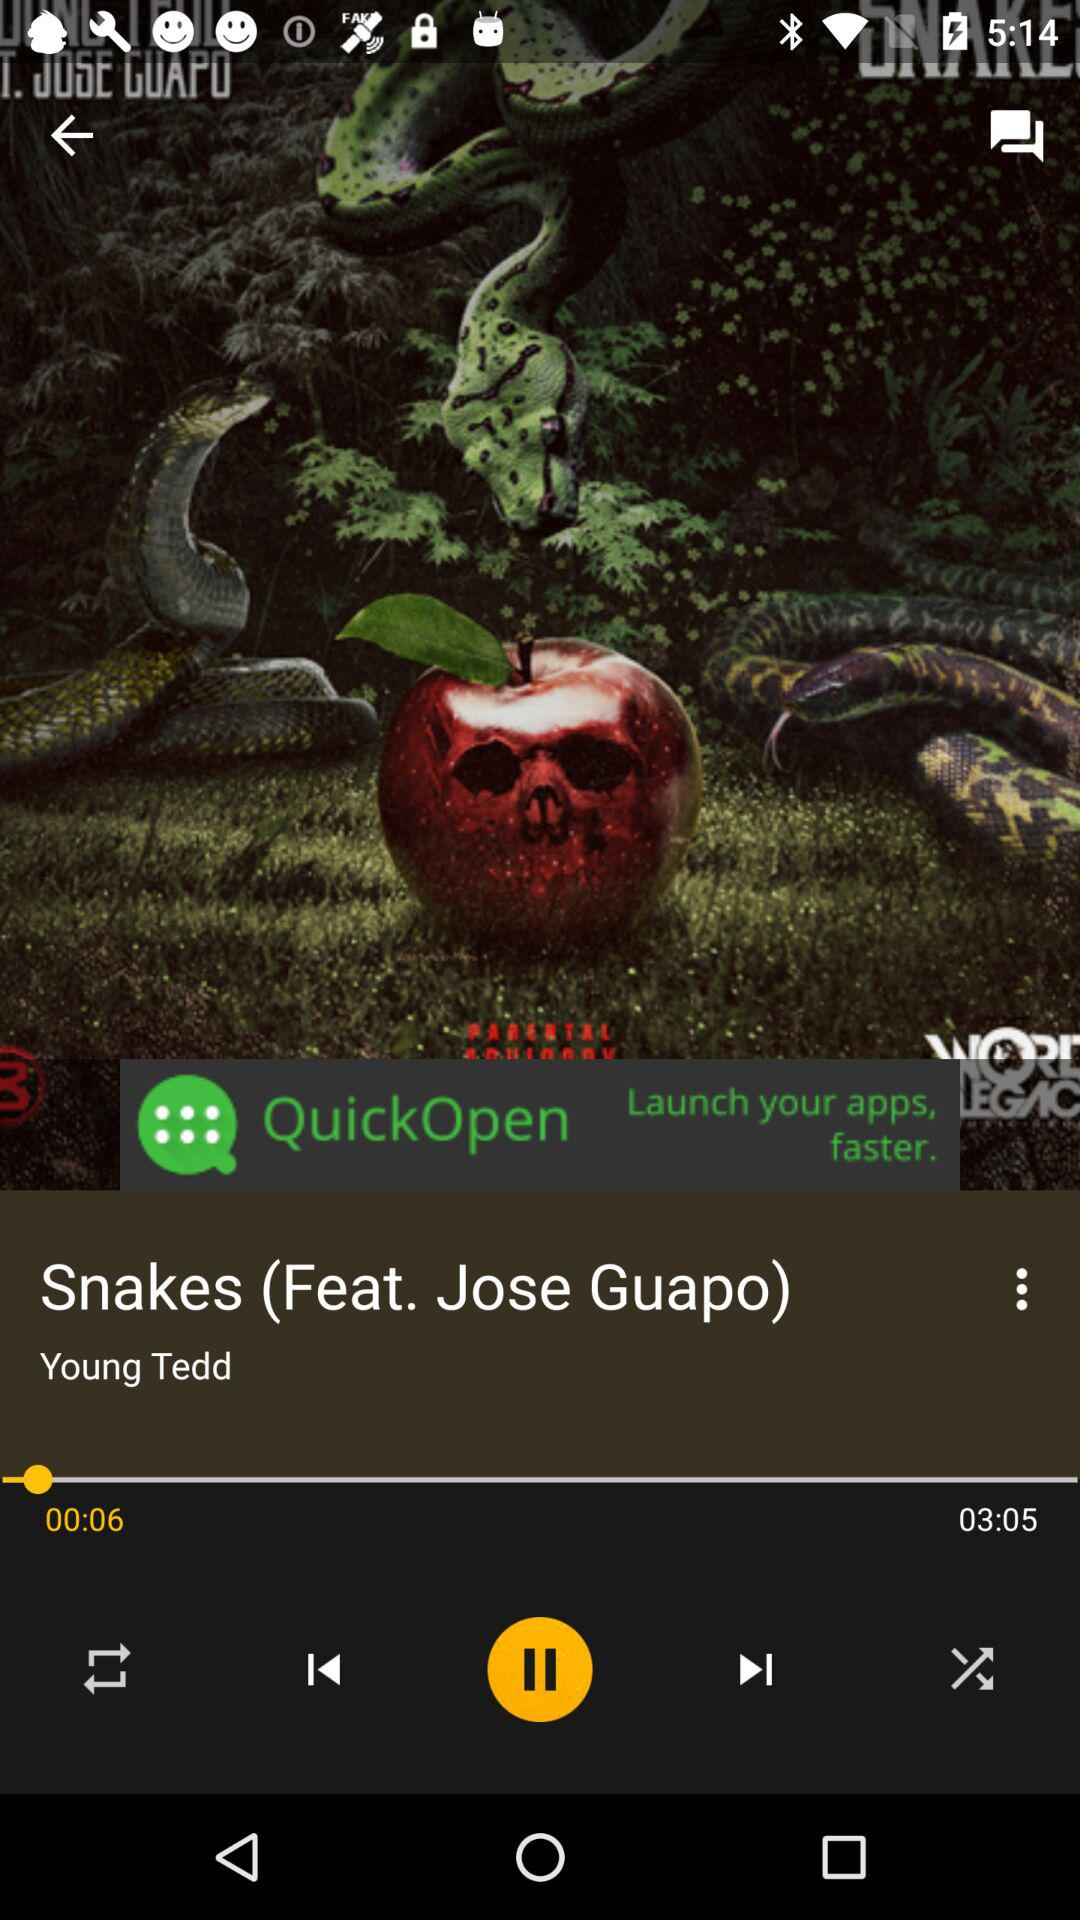Which song is currently playing? The currently playing song is "Snakes". 